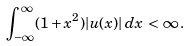Convert formula to latex. <formula><loc_0><loc_0><loc_500><loc_500>\int _ { - \infty } ^ { \infty } ( 1 + x ^ { 2 } ) | u ( x ) | \, d x \, < \, \infty \, .</formula> 